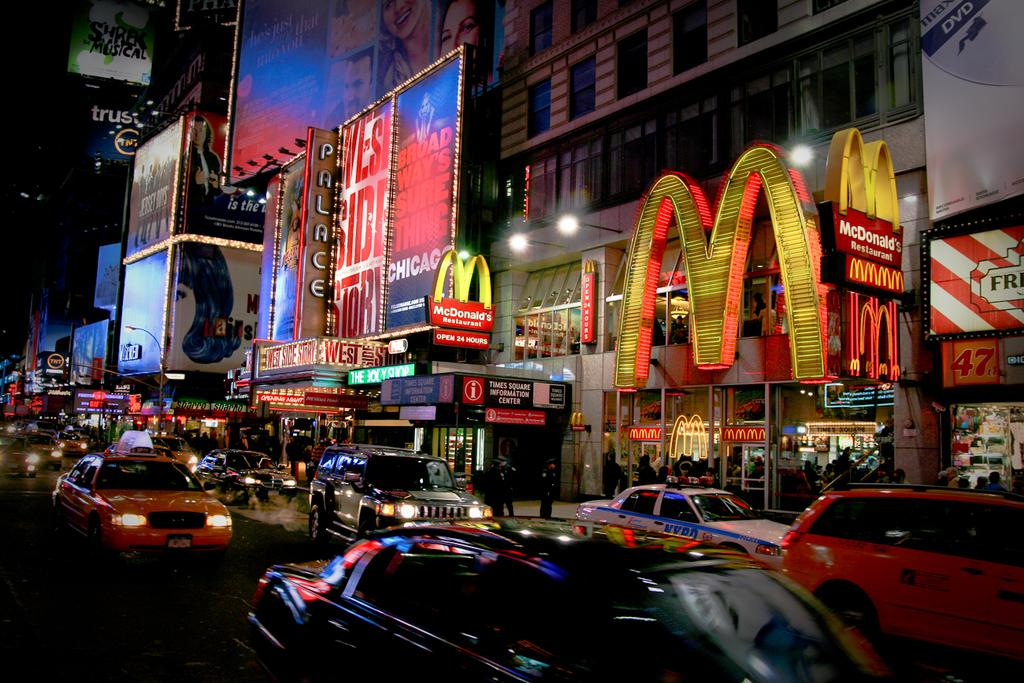<image>
Provide a brief description of the given image. Several veicles are driving down a street with a large mcdonalds logo visible on the restaurant. 